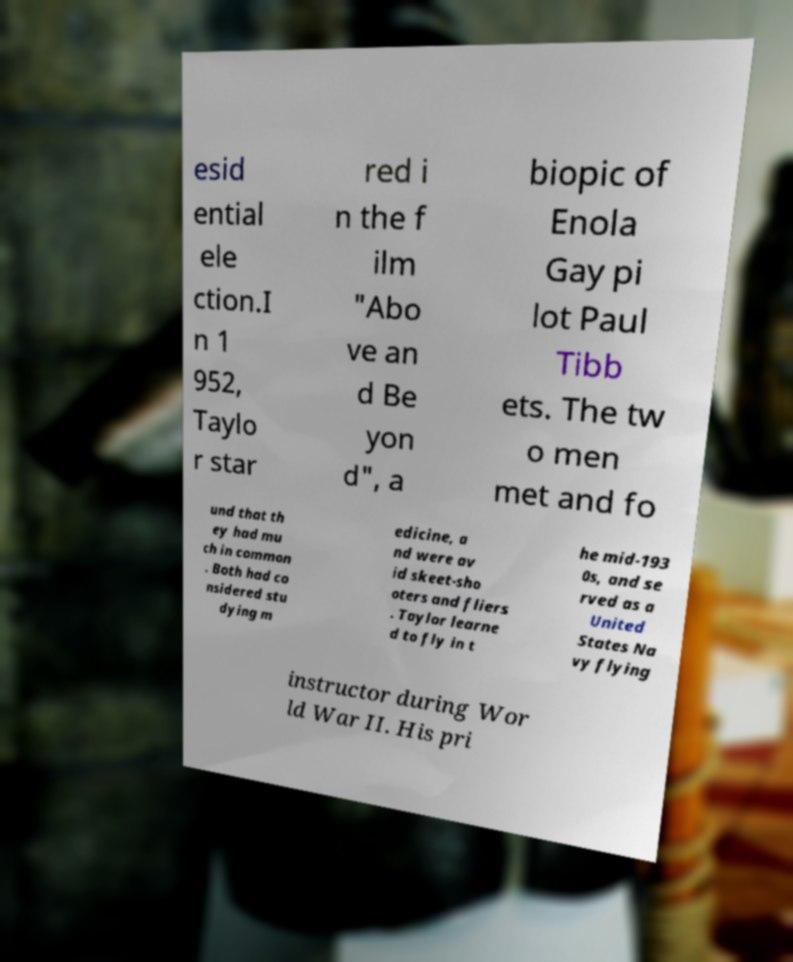Could you assist in decoding the text presented in this image and type it out clearly? esid ential ele ction.I n 1 952, Taylo r star red i n the f ilm "Abo ve an d Be yon d", a biopic of Enola Gay pi lot Paul Tibb ets. The tw o men met and fo und that th ey had mu ch in common . Both had co nsidered stu dying m edicine, a nd were av id skeet-sho oters and fliers . Taylor learne d to fly in t he mid-193 0s, and se rved as a United States Na vy flying instructor during Wor ld War II. His pri 